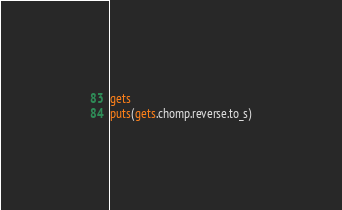Convert code to text. <code><loc_0><loc_0><loc_500><loc_500><_Ruby_>gets
puts(gets.chomp.reverse.to_s)

</code> 